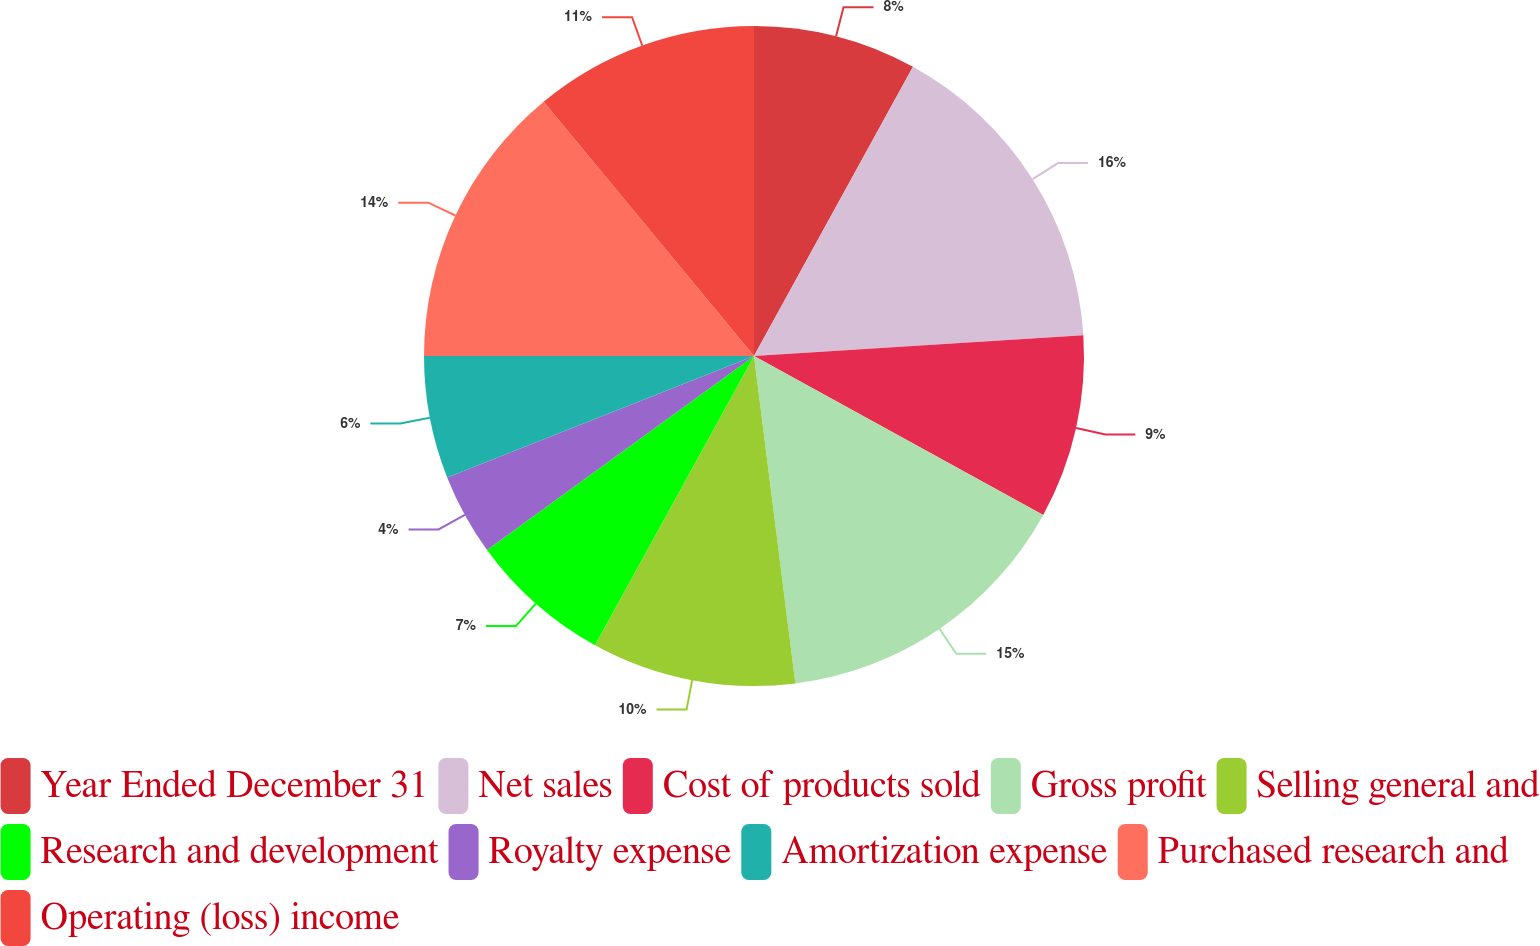Convert chart to OTSL. <chart><loc_0><loc_0><loc_500><loc_500><pie_chart><fcel>Year Ended December 31<fcel>Net sales<fcel>Cost of products sold<fcel>Gross profit<fcel>Selling general and<fcel>Research and development<fcel>Royalty expense<fcel>Amortization expense<fcel>Purchased research and<fcel>Operating (loss) income<nl><fcel>8.0%<fcel>16.0%<fcel>9.0%<fcel>15.0%<fcel>10.0%<fcel>7.0%<fcel>4.0%<fcel>6.0%<fcel>14.0%<fcel>11.0%<nl></chart> 